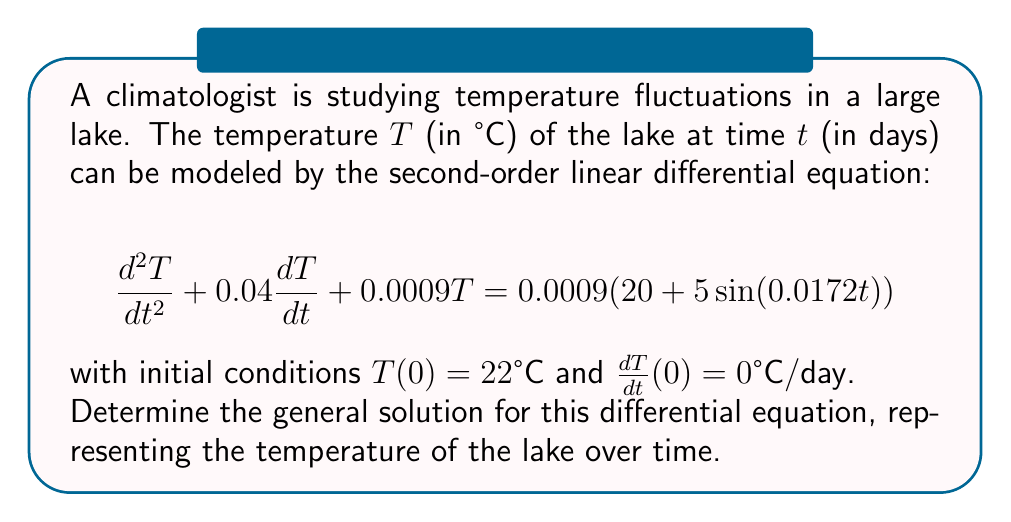Help me with this question. To solve this second-order linear differential equation, we'll follow these steps:

1) First, identify the homogeneous and particular solutions:
   The general solution will be of the form $T(t) = T_h(t) + T_p(t)$, where $T_h(t)$ is the homogeneous solution and $T_p(t)$ is the particular solution.

2) For the homogeneous part $\frac{d^2T}{dt^2} + 0.04\frac{dT}{dt} + 0.0009T = 0$:
   Assume a solution of the form $T_h(t) = e^{rt}$. Substituting this into the homogeneous equation:
   $r^2e^{rt} + 0.04re^{rt} + 0.0009e^{rt} = 0$
   $e^{rt}(r^2 + 0.04r + 0.0009) = 0$
   
   The characteristic equation is: $r^2 + 0.04r + 0.0009 = 0$
   
   Solving this quadratic equation:
   $r = \frac{-0.04 \pm \sqrt{0.04^2 - 4(1)(0.0009)}}{2(1)}$
   $r = -0.02 \pm 0.01$
   
   So, $r_1 = -0.03$ and $r_2 = -0.01$

   Therefore, the homogeneous solution is:
   $T_h(t) = C_1e^{-0.03t} + C_2e^{-0.01t}$

3) For the particular solution, we assume a form:
   $T_p(t) = A + B\sin(0.0172t) + C\cos(0.0172t)$
   
   Substituting this into the original equation and equating coefficients, we get:
   $A = 20$, $B = 5$, $C = 0$

   So, $T_p(t) = 20 + 5\sin(0.0172t)$

4) The general solution is:
   $T(t) = T_h(t) + T_p(t) = C_1e^{-0.03t} + C_2e^{-0.01t} + 20 + 5\sin(0.0172t)$

Therefore, the general solution representing the temperature of the lake over time is:

$T(t) = C_1e^{-0.03t} + C_2e^{-0.01t} + 20 + 5\sin(0.0172t)$

where $C_1$ and $C_2$ are constants that can be determined using the initial conditions.
Answer: $T(t) = C_1e^{-0.03t} + C_2e^{-0.01t} + 20 + 5\sin(0.0172t)$ 